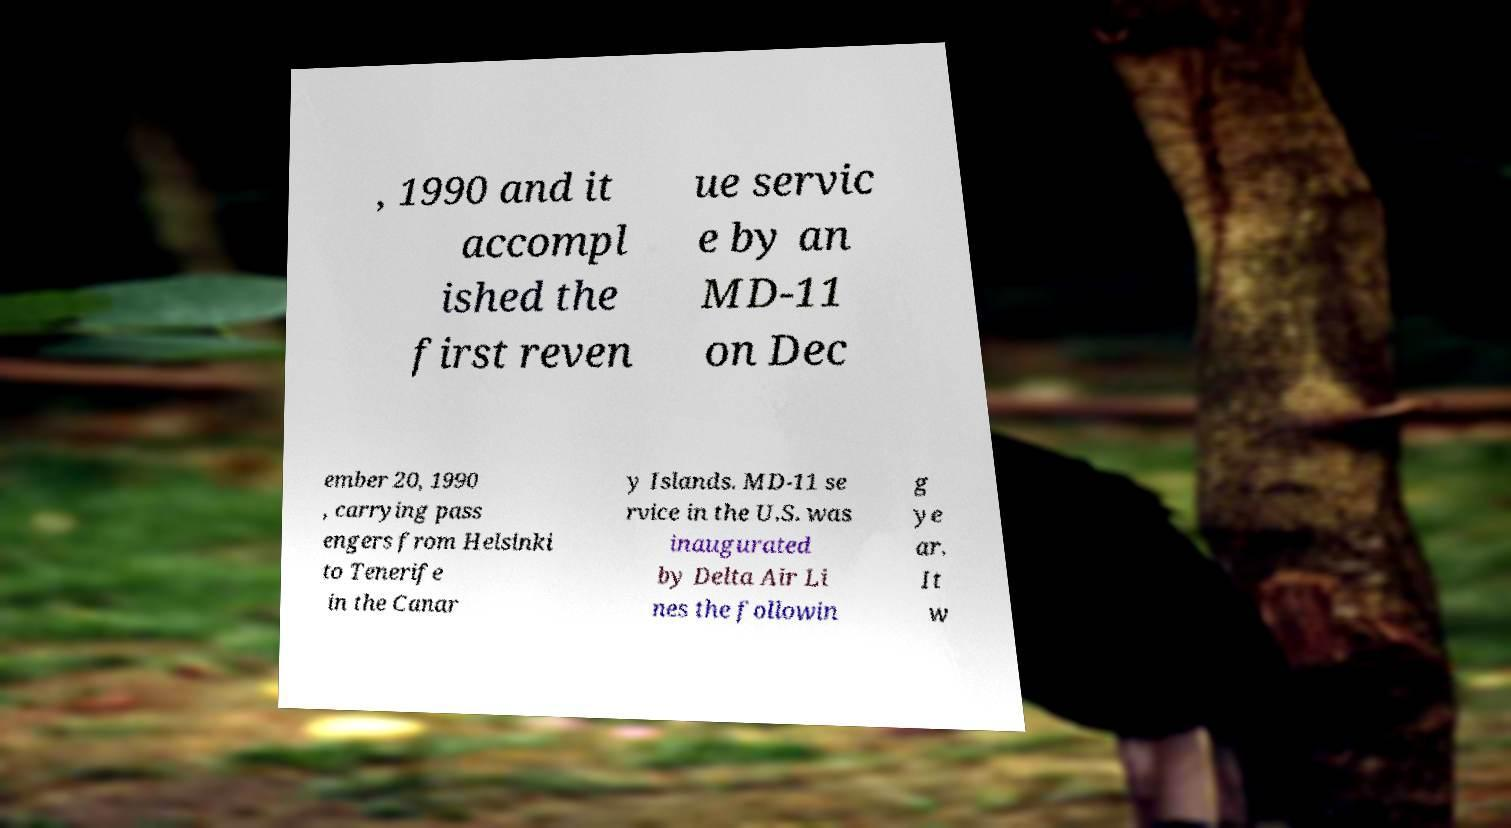Could you assist in decoding the text presented in this image and type it out clearly? , 1990 and it accompl ished the first reven ue servic e by an MD-11 on Dec ember 20, 1990 , carrying pass engers from Helsinki to Tenerife in the Canar y Islands. MD-11 se rvice in the U.S. was inaugurated by Delta Air Li nes the followin g ye ar. It w 